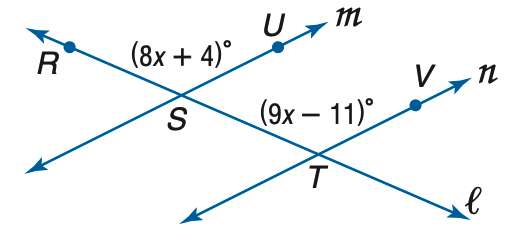Question: Find m \angle R S U so that m \parallel n.
Choices:
A. 114
B. 116
C. 120
D. 124
Answer with the letter. Answer: D Question: Find x so that m \parallel n.
Choices:
A. 7
B. 11
C. 15
D. 19
Answer with the letter. Answer: C 